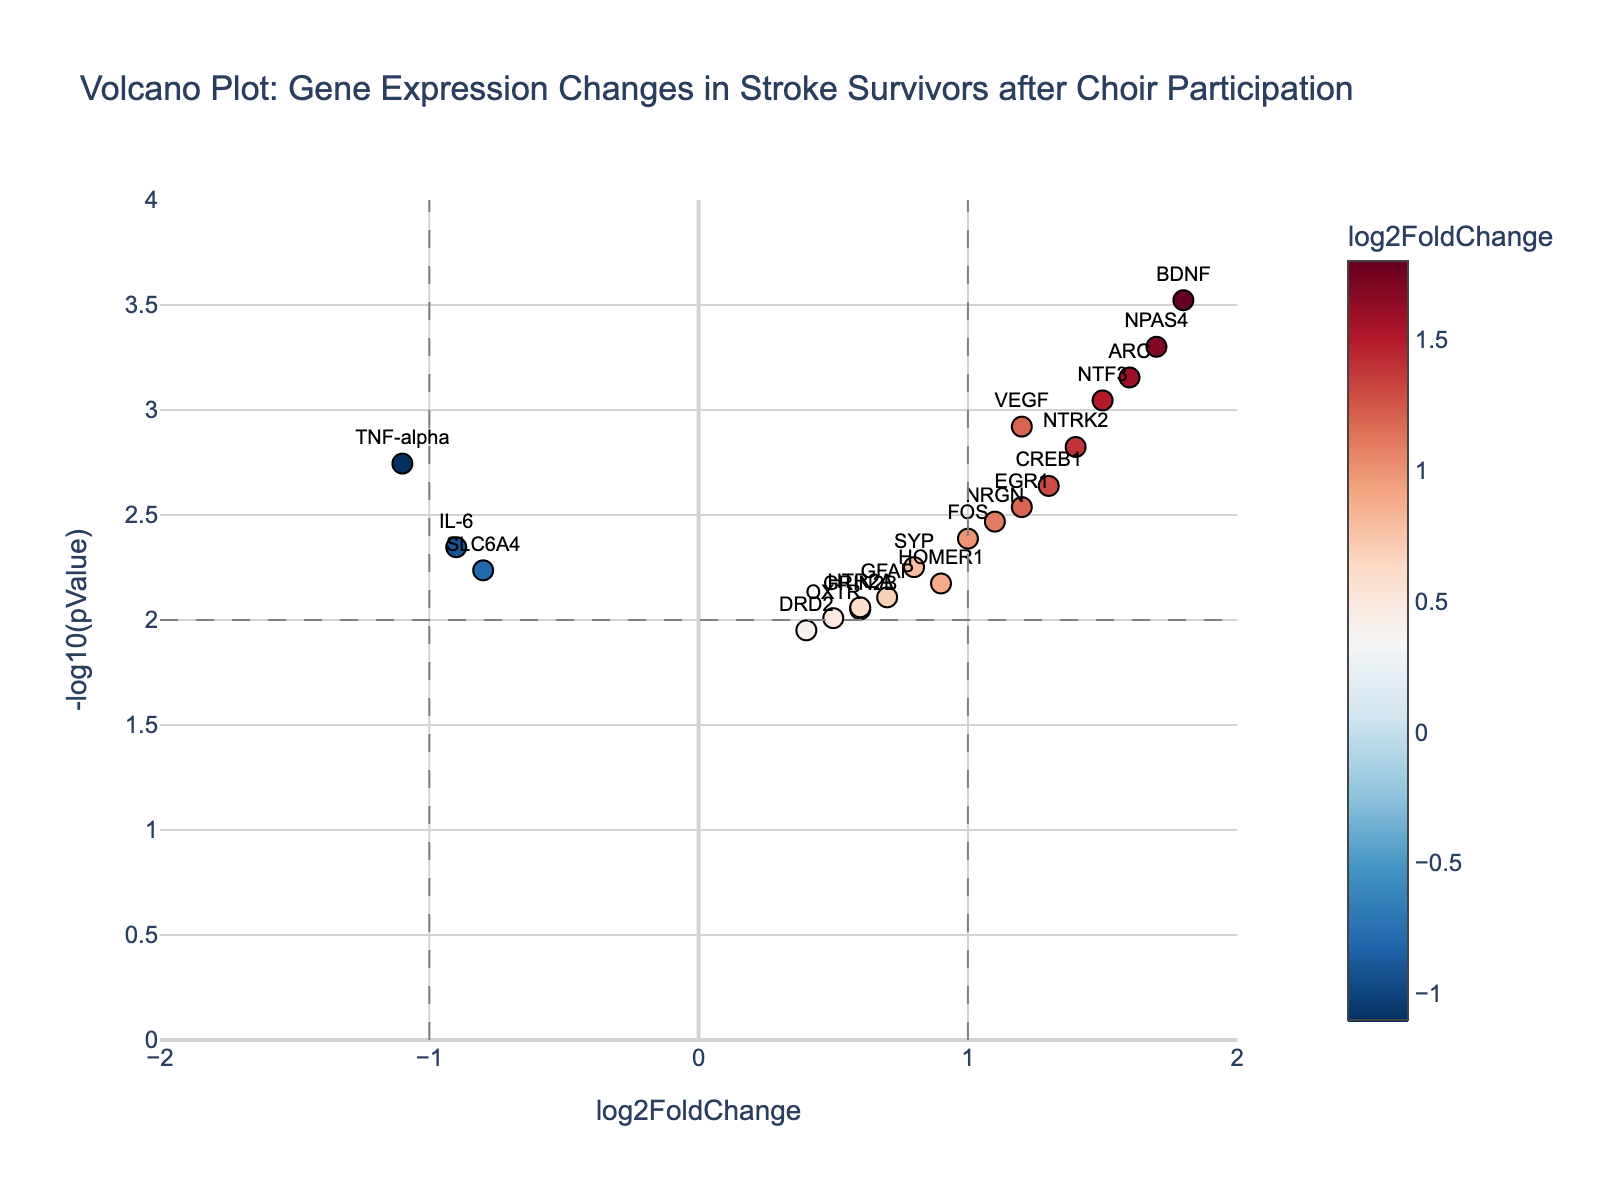What is the title of the plot? The title is usually found at the top of the plot and is designated to describe what the plot represents. Here, it's "Volcano Plot: Gene Expression Changes in Stroke Survivors after Choir Participation."
Answer: Volcano Plot: Gene Expression Changes in Stroke Survivors after Choir Participation How many genes have a log2FoldChange greater than 1 and a -log10(pValue) greater than 2? Review the plot and count the data points where the log2FoldChange on the x-axis is greater than 1 and the -log10(pValue) on the y-axis is greater than 2.
Answer: 5 Which gene has the highest log2FoldChange value and what is that value? Find the data point on the x-axis with the highest log2FoldChange value. The gene associated with this point is NPAS4 and the value is 1.8.
Answer: NPAS4, 1.8 What are the threshold lines for log2FoldChange and pValue on the plot? The thresholds are marked by vertical and horizontal dashed lines. Vertical lines at log2FoldChange = ±1, and the horizontal line at -log10(pValue) = 2.
Answer: ±1 for log2FoldChange, 2 for -log10(pValue) Which gene has the smallest pValue and what is its log2FoldChange? Identify the gene with the smallest pValue by finding the highest -log10(pValue) on the plot. The smallest pValue corresponds to the highest point on the y-axis. This gene is BDNF, and its log2FoldChange is 1.8.
Answer: BDNF, 1.8 How many genes have a log2FoldChange less than -1 and -log10(pValue) greater than 2? Review the plot and count the data points where the log2FoldChange is less than -1 and the -log10(pValue) is greater than 2. There are no such points visible.
Answer: 0 What is the range of the log2FoldChange and -log10(pValue) axes? The range of the x-axis (log2FoldChange) is from -2 to 2, while the range of the y-axis (-log10(pValue)) is from 0 to 4.
Answer: -2 to 2 for log2FoldChange, 0 to 4 for -log10(pValue) Which gene has a log2FoldChange greater than 1.5 and what is its pValue? Look at the plot to find the genes with log2FoldChange values greater than 1.5. NTF3 and NPAS4 are such genes. Their pValues are 0.0009 and 0.0005, respectively.
Answer: NTF3, 0.0009 and NPAS4, 0.0005 How many genes have both positive log2FoldChange and a statistically significant pValue (p < 0.01)? Review the plot and count the data points with a positive log2FoldChange and a corresponding -log10(pValue) greater than 2 (indicating p < 0.01). There are 8 such genes.
Answer: 8 Which gene has the log2FoldChange closest to 0, and what is its pValue? Find the data point nearest to 0 on the log2FoldChange axis. This gene is DRD2, with a log2FoldChange of 0.4 and a pValue of 0.0112.
Answer: DRD2, 0.0112 